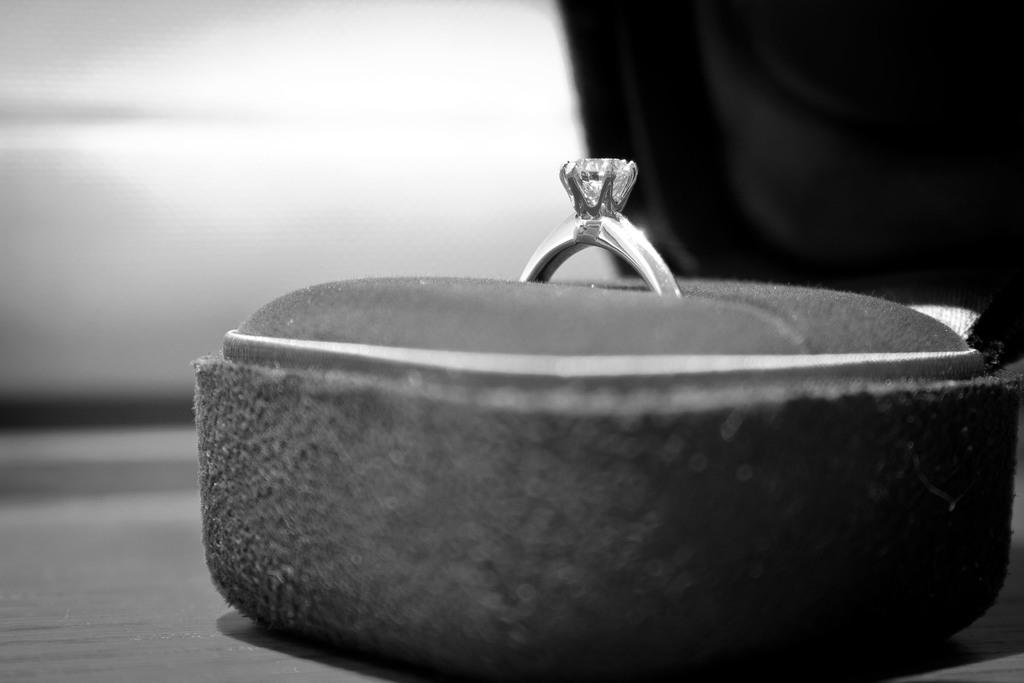What object is on the surface in the image? There is a box on the surface in the image. What is inside the box? There is a ring inside the box. Can you describe the background of the image? The background of the image is blurry. What month is depicted in the image? There is no month depicted in the image; it features a box with a ring inside and a blurry background. Can you see a monkey in the image? There is no monkey present in the image. 